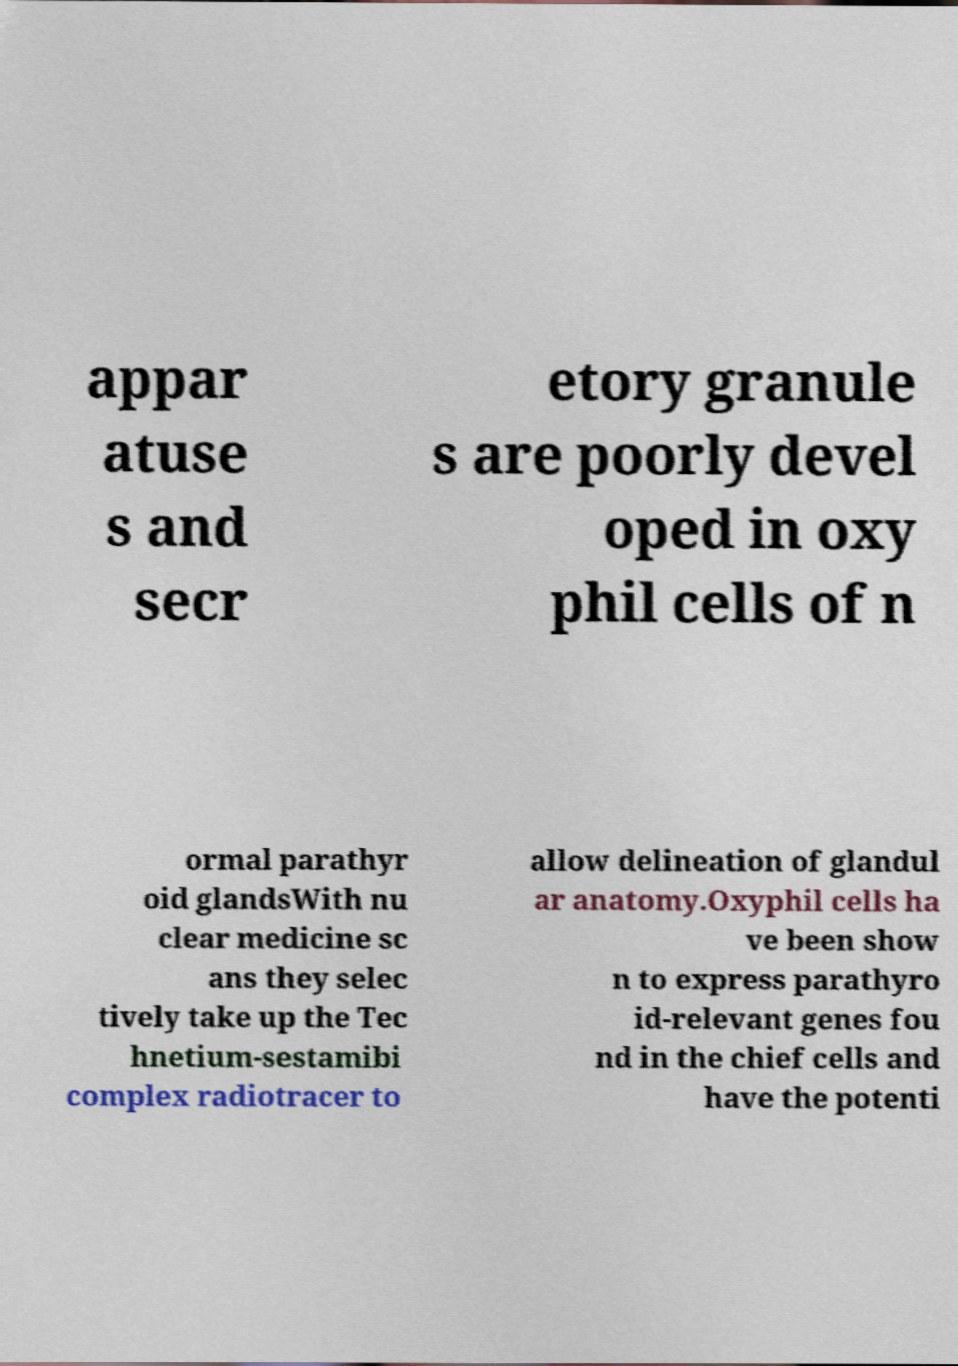For documentation purposes, I need the text within this image transcribed. Could you provide that? appar atuse s and secr etory granule s are poorly devel oped in oxy phil cells of n ormal parathyr oid glandsWith nu clear medicine sc ans they selec tively take up the Tec hnetium-sestamibi complex radiotracer to allow delineation of glandul ar anatomy.Oxyphil cells ha ve been show n to express parathyro id-relevant genes fou nd in the chief cells and have the potenti 